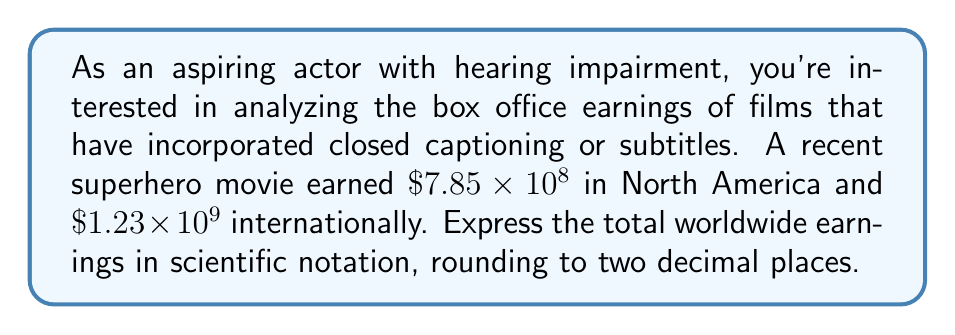Help me with this question. Let's approach this step-by-step:

1) We have two numbers in scientific notation:
   North American earnings: $7.85 \times 10^8$
   International earnings: $1.23 \times 10^9$

2) To add these, we need to convert them to the same power of 10:
   $7.85 \times 10^8 = 0.785 \times 10^9$

3) Now we can add:
   $(0.785 + 1.23) \times 10^9 = 2.015 \times 10^9$

4) Rounding to two decimal places:
   $2.02 \times 10^9$

This result represents the total worldwide earnings in scientific notation, rounded to two decimal places.
Answer: $2.02 \times 10^9$ 